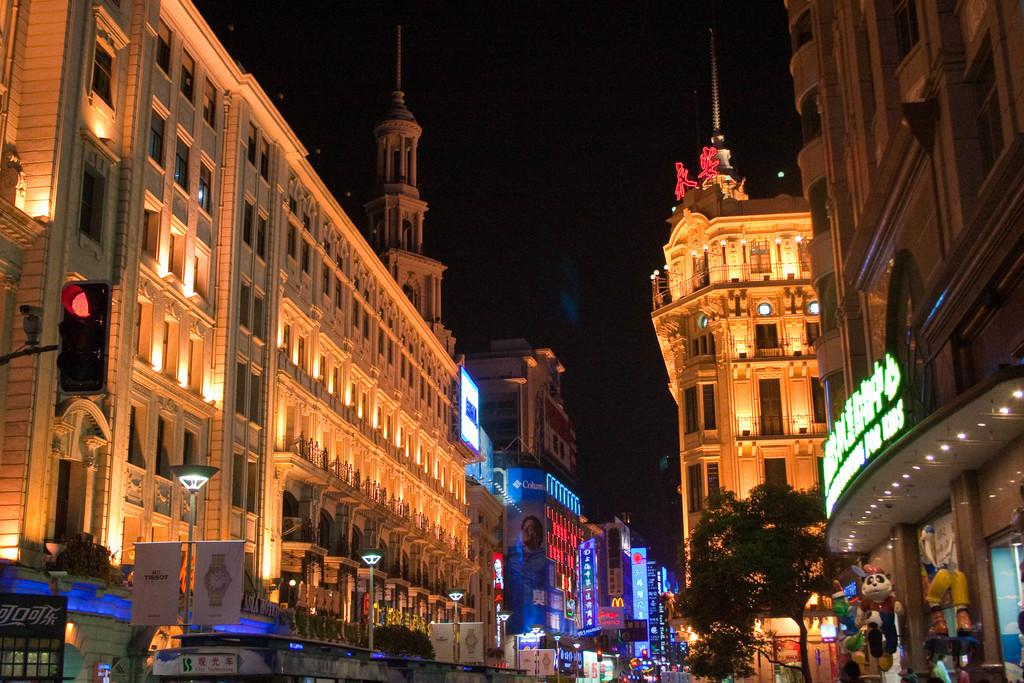What structures are present in the image? There are buildings in the image. What type of vegetation can be seen on the right side of the image? There is a tree on the right side of the image. What part of the natural environment is visible in the image? The sky is visible in the background of the image. How would you describe the appearance of the sky in the image? The sky in the background is completely dark. How many dimes can be seen on the tree in the image? There are no dimes present on the tree in the image. Is there a drain visible in the image? There is no drain present in the image. 